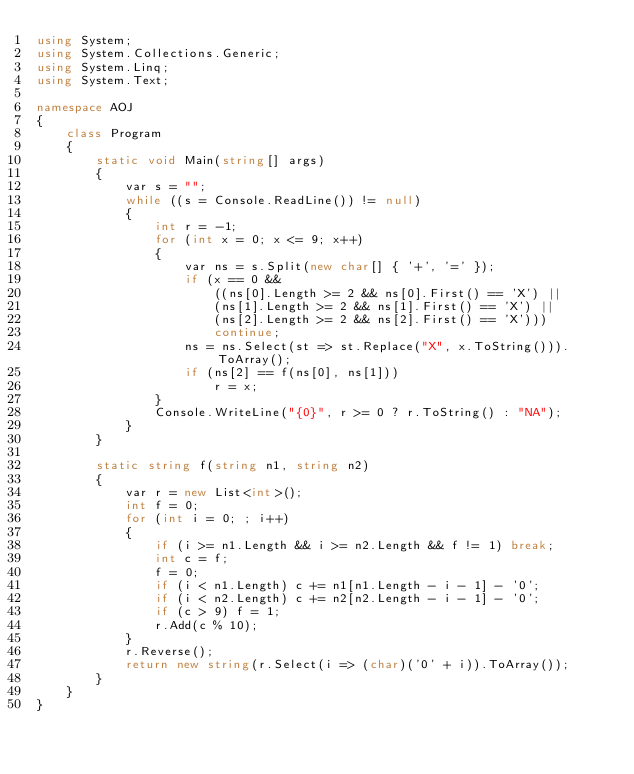<code> <loc_0><loc_0><loc_500><loc_500><_C#_>using System;
using System.Collections.Generic;
using System.Linq;
using System.Text;

namespace AOJ
{
	class Program
	{
		static void Main(string[] args)
		{
			var s = "";
			while ((s = Console.ReadLine()) != null)
			{
				int r = -1;
				for (int x = 0; x <= 9; x++)
				{
					var ns = s.Split(new char[] { '+', '=' });
					if (x == 0 &&
						((ns[0].Length >= 2 && ns[0].First() == 'X') ||
						(ns[1].Length >= 2 && ns[1].First() == 'X') ||
						(ns[2].Length >= 2 && ns[2].First() == 'X')))
						continue;
					ns = ns.Select(st => st.Replace("X", x.ToString())).ToArray();
					if (ns[2] == f(ns[0], ns[1]))
						r = x;
				}
				Console.WriteLine("{0}", r >= 0 ? r.ToString() : "NA");
			}
		}

		static string f(string n1, string n2)
		{
			var r = new List<int>();
			int f = 0;
			for (int i = 0; ; i++)
			{
				if (i >= n1.Length && i >= n2.Length && f != 1) break;
				int c = f;
				f = 0;
				if (i < n1.Length) c += n1[n1.Length - i - 1] - '0';
				if (i < n2.Length) c += n2[n2.Length - i - 1] - '0';
				if (c > 9) f = 1;
				r.Add(c % 10);
			}
			r.Reverse();
			return new string(r.Select(i => (char)('0' + i)).ToArray());
		}
	}
}</code> 